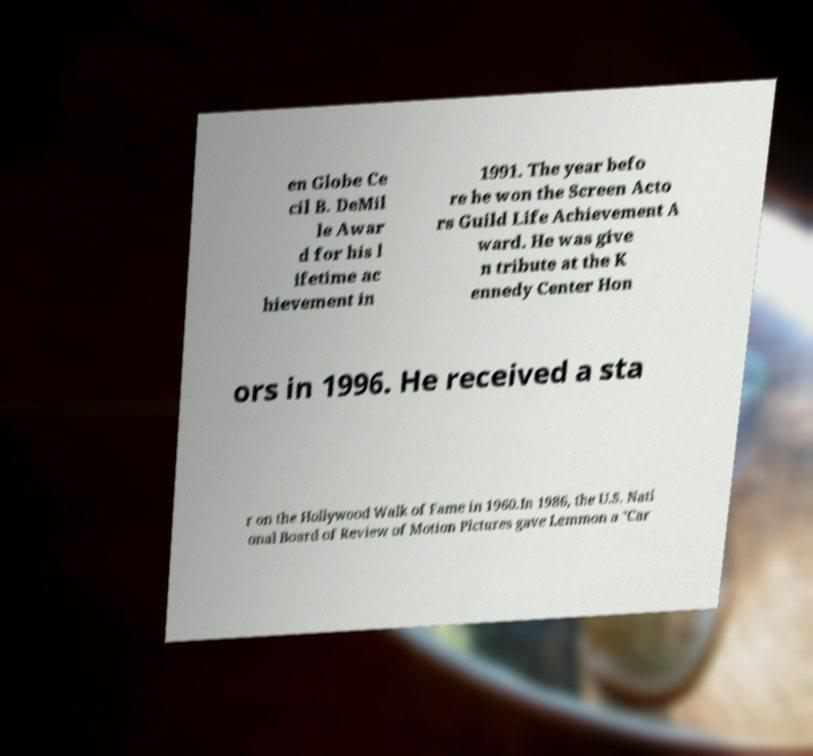I need the written content from this picture converted into text. Can you do that? en Globe Ce cil B. DeMil le Awar d for his l ifetime ac hievement in 1991. The year befo re he won the Screen Acto rs Guild Life Achievement A ward. He was give n tribute at the K ennedy Center Hon ors in 1996. He received a sta r on the Hollywood Walk of Fame in 1960.In 1986, the U.S. Nati onal Board of Review of Motion Pictures gave Lemmon a "Car 